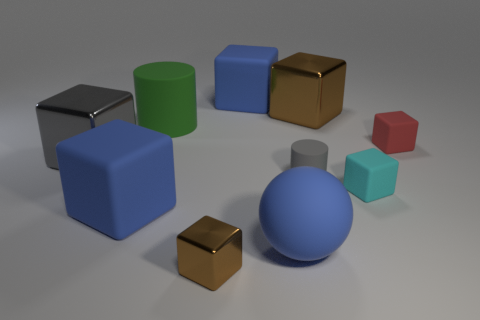What is the material of the large object that is the same color as the tiny metallic thing?
Ensure brevity in your answer.  Metal. Are there an equal number of small cyan rubber objects in front of the rubber sphere and large spheres?
Offer a very short reply. No. Do the green object and the rubber ball have the same size?
Provide a short and direct response. Yes. The metallic thing that is both behind the cyan thing and on the left side of the small gray matte cylinder is what color?
Your answer should be very brief. Gray. The cyan block behind the blue sphere that is left of the cyan rubber object is made of what material?
Provide a short and direct response. Rubber. There is a gray thing that is the same shape as the red thing; what is its size?
Offer a very short reply. Large. Do the large cube right of the blue rubber sphere and the small metal object have the same color?
Offer a terse response. Yes. Are there fewer brown objects than small gray rubber objects?
Ensure brevity in your answer.  No. How many other objects are there of the same color as the small metal block?
Ensure brevity in your answer.  1. Are the brown cube behind the large green thing and the small brown thing made of the same material?
Offer a very short reply. Yes. 